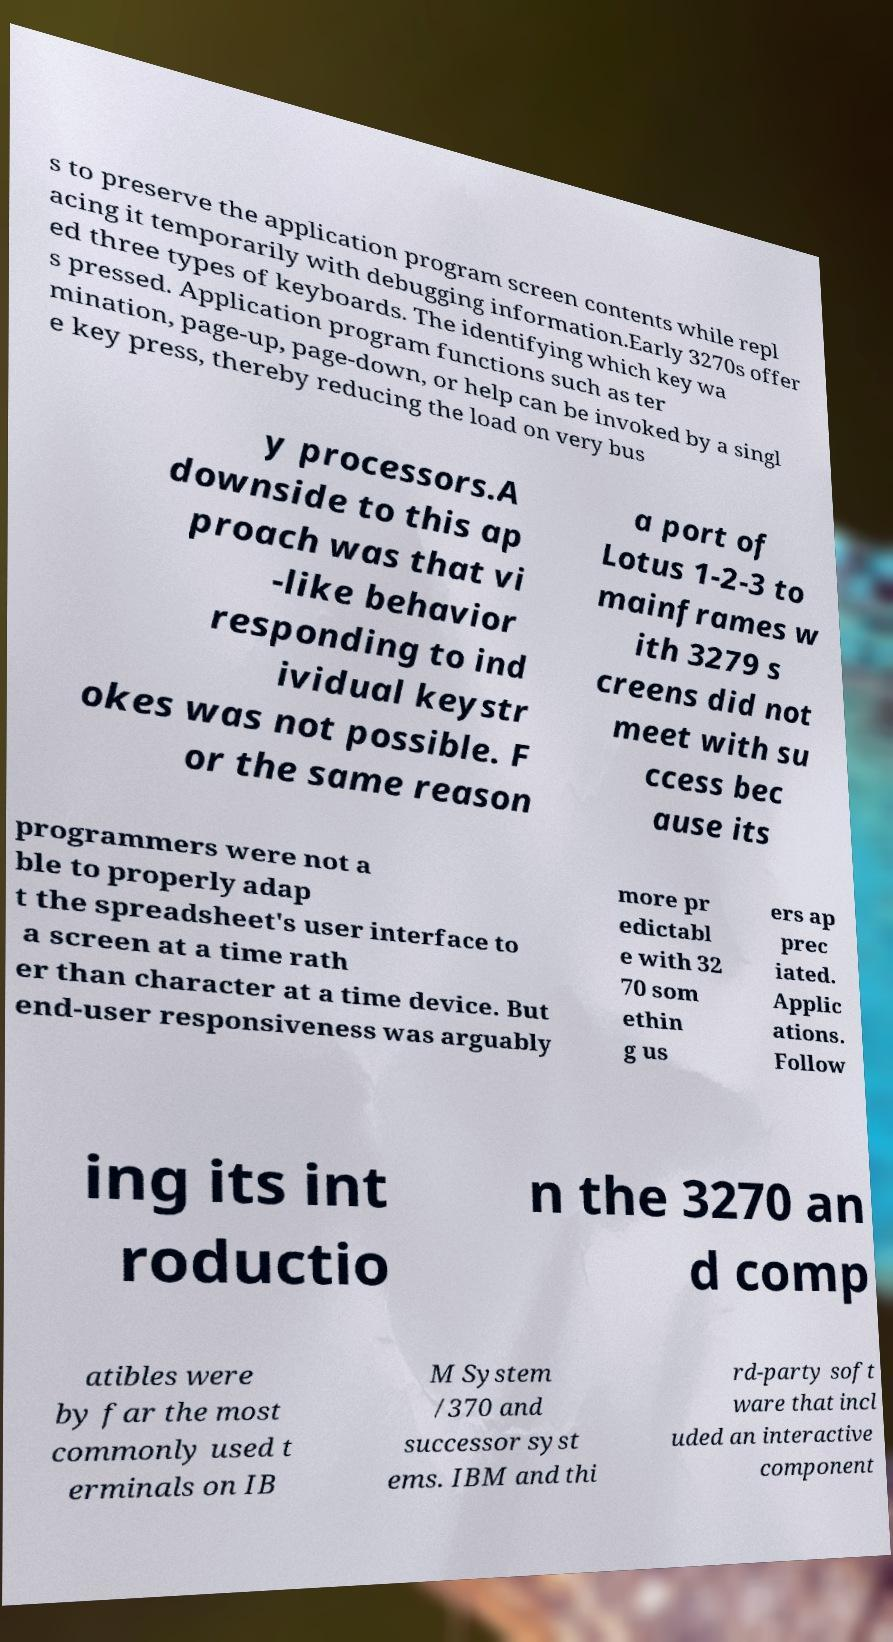Could you extract and type out the text from this image? s to preserve the application program screen contents while repl acing it temporarily with debugging information.Early 3270s offer ed three types of keyboards. The identifying which key wa s pressed. Application program functions such as ter mination, page-up, page-down, or help can be invoked by a singl e key press, thereby reducing the load on very bus y processors.A downside to this ap proach was that vi -like behavior responding to ind ividual keystr okes was not possible. F or the same reason a port of Lotus 1-2-3 to mainframes w ith 3279 s creens did not meet with su ccess bec ause its programmers were not a ble to properly adap t the spreadsheet's user interface to a screen at a time rath er than character at a time device. But end-user responsiveness was arguably more pr edictabl e with 32 70 som ethin g us ers ap prec iated. Applic ations. Follow ing its int roductio n the 3270 an d comp atibles were by far the most commonly used t erminals on IB M System /370 and successor syst ems. IBM and thi rd-party soft ware that incl uded an interactive component 